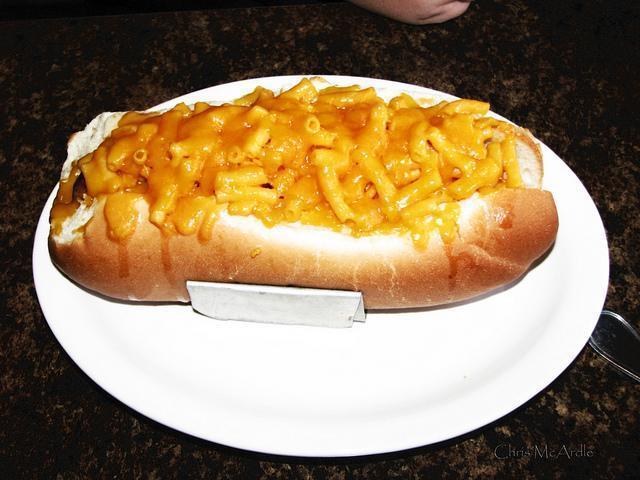What type of food is on top of the bread?
Choose the right answer and clarify with the format: 'Answer: answer
Rationale: rationale.'
Options: Fruit, vegetables, noodles, meat. Answer: noodles.
Rationale: The food on top is macaroni and cheese judging by the appearance and answer a is a component of macaroni and cheese. 